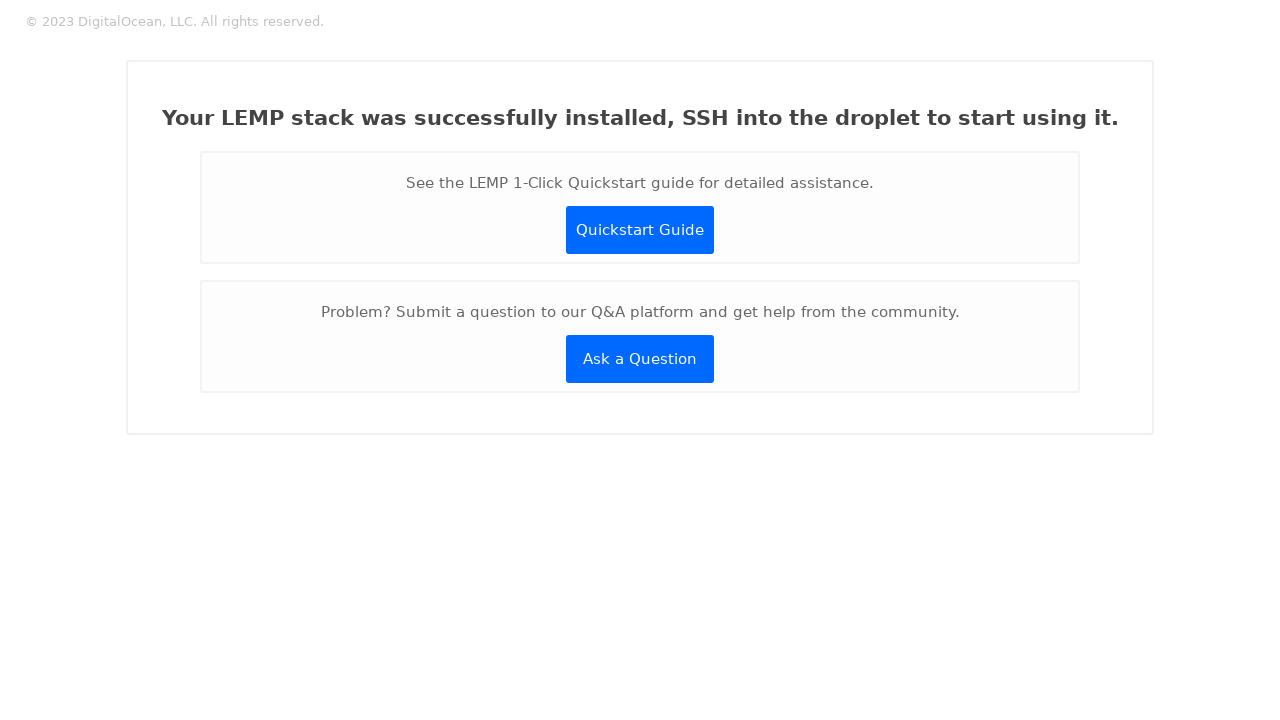Can you explain how to customize the design of the buttons shown in the image? To customize the buttons displayed in the image, you would modify the CSS properties within the '.button' class. You could change the 'background-color' to match your company's brand color, adjust the 'border-radius' for sharper or more rounded corners, or update the 'color' for text to enhance visibility. It's also possible to add effects like hover actions with CSS pseudo-classes to make the interface more interactive and visually appealing. 